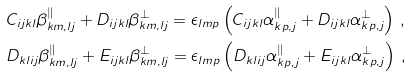<formula> <loc_0><loc_0><loc_500><loc_500>& C _ { i j k l } \beta _ { k m , l j } ^ { \| } + D _ { i j k l } \beta _ { k m , l j } ^ { \bot } = \epsilon _ { l m p } \left ( C _ { i j k l } { \alpha } ^ { \| } _ { k p , j } + D _ { i j k l } { \alpha } ^ { \bot } _ { k p , j } \right ) \, , \\ & D _ { k l i j } \beta _ { k m , l j } ^ { \| } + E _ { i j k l } \beta _ { k m , l j } ^ { \bot } = \epsilon _ { l m p } \left ( D _ { k l i j } { \alpha } ^ { \| } _ { k p , j } + E _ { i j k l } { \alpha } ^ { \bot } _ { k p , j } \right ) \, ,</formula> 